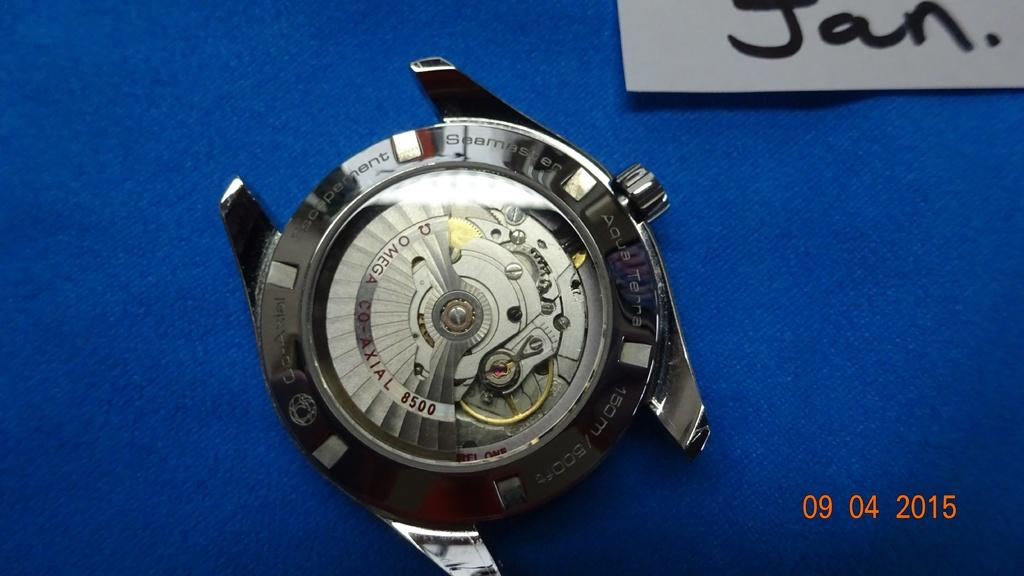<image>
Summarize the visual content of the image. The inside of a watch sits on a blue background with a whites sign above it and in black letters it says Jan. 